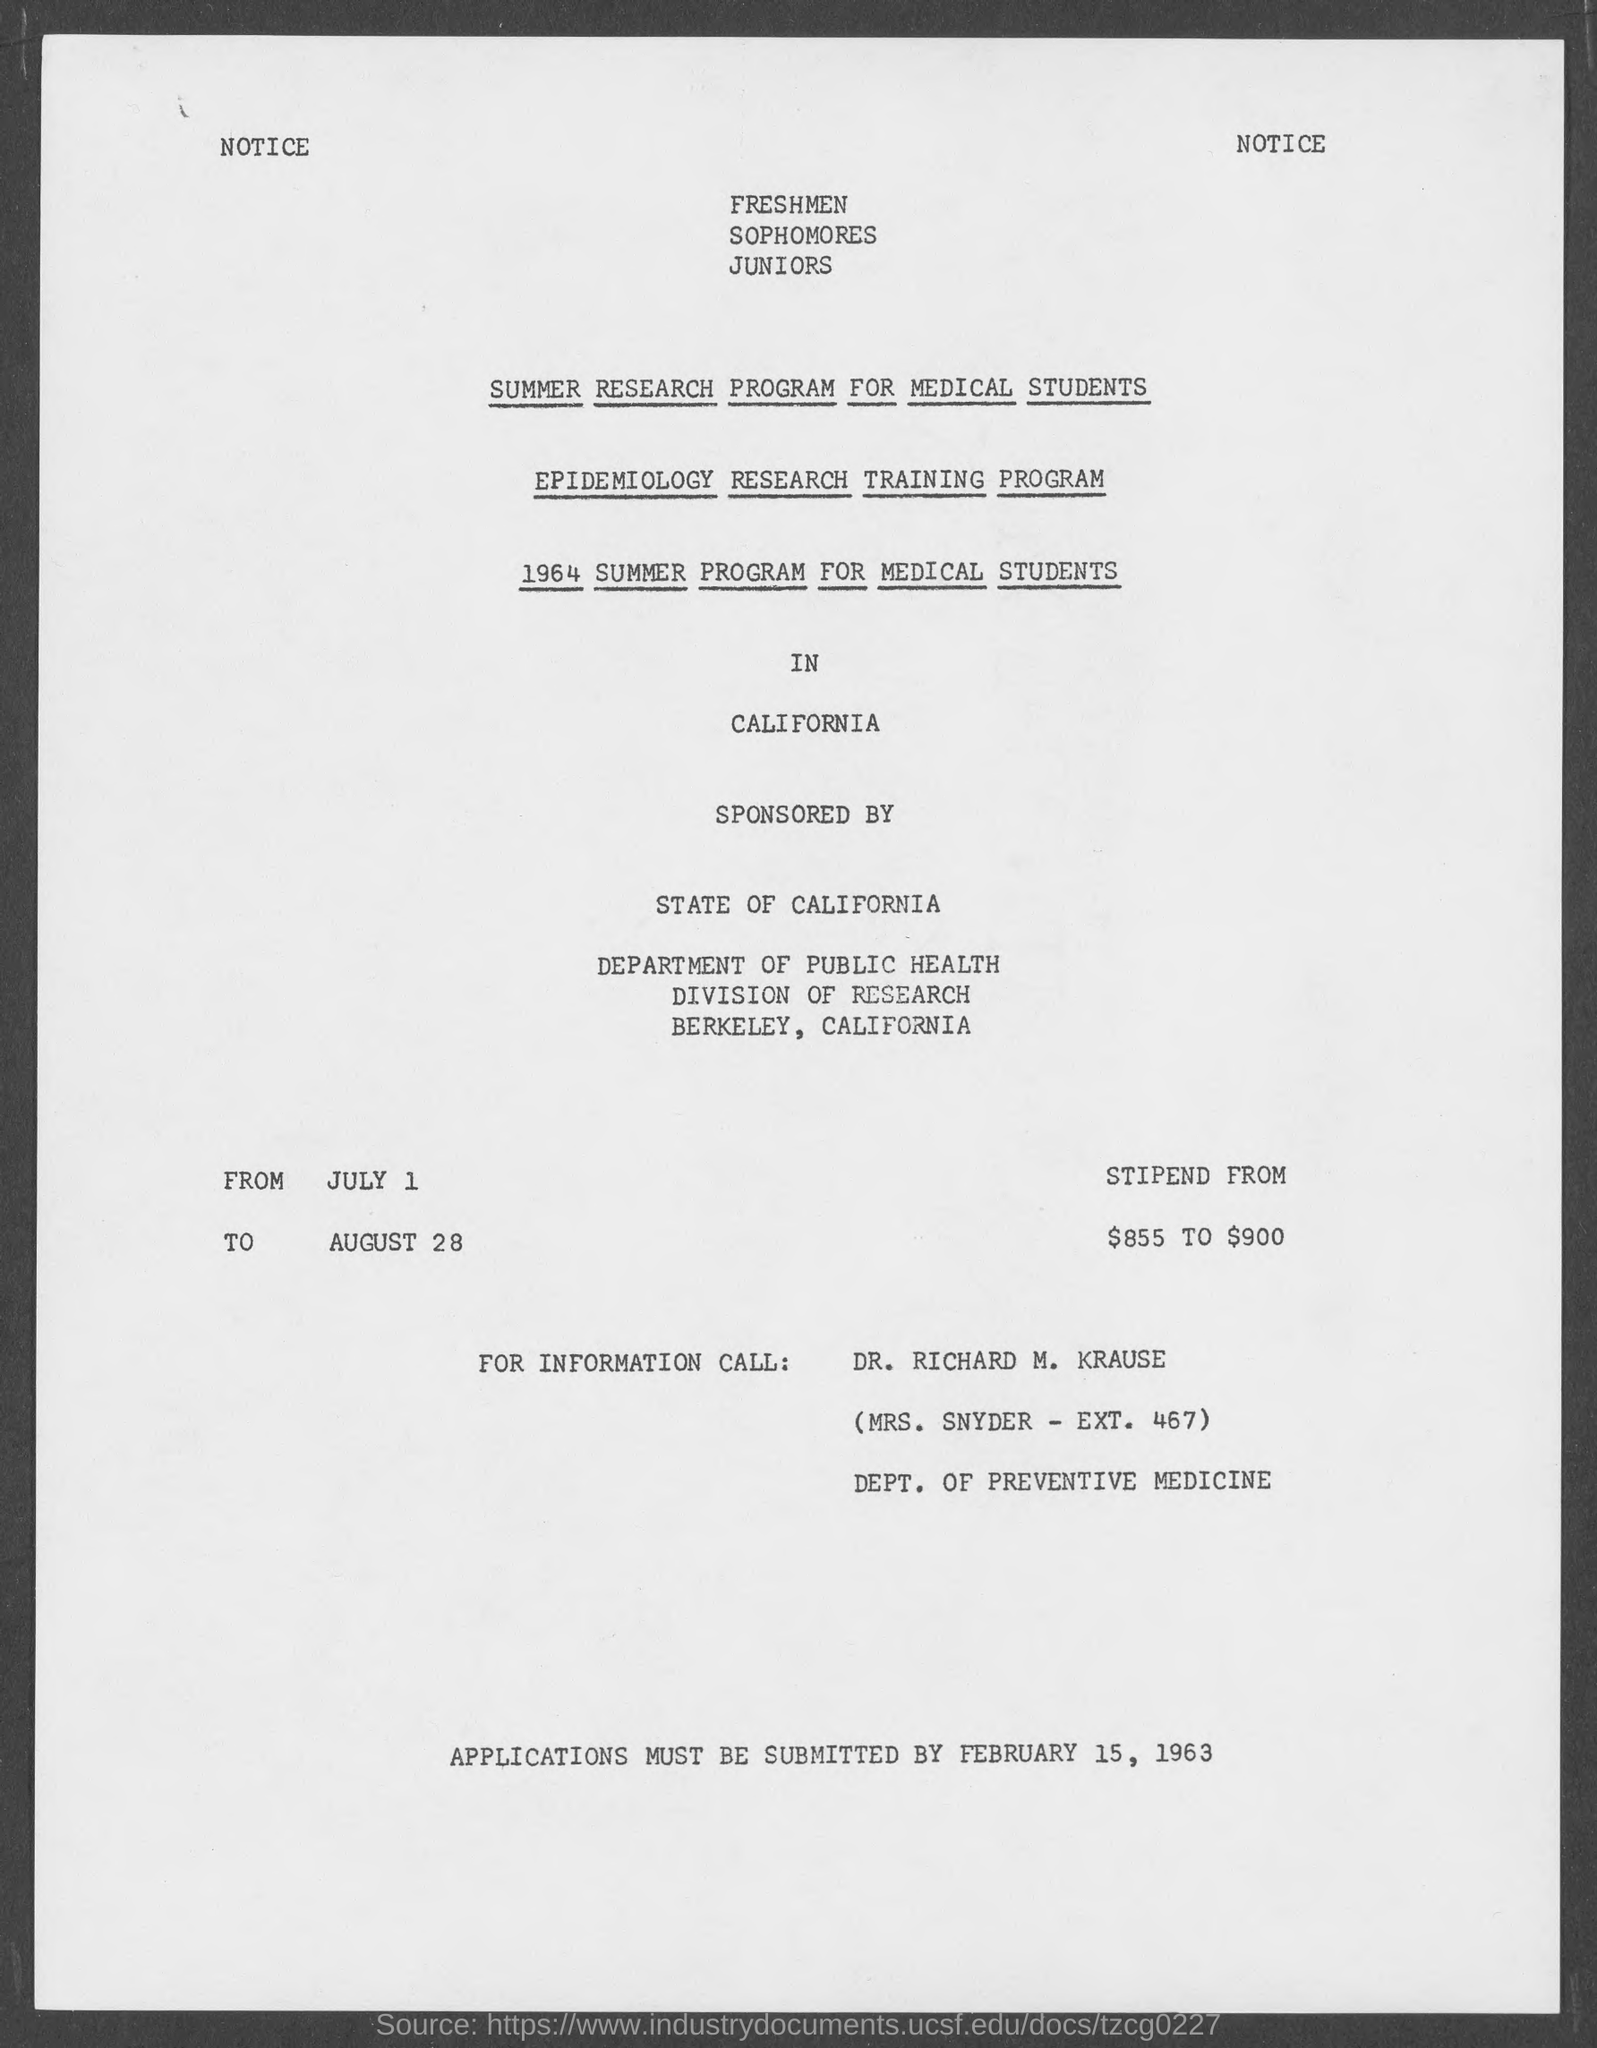Indicate a few pertinent items in this graphic. The last date for the submission of applications was February 15, 1963. 